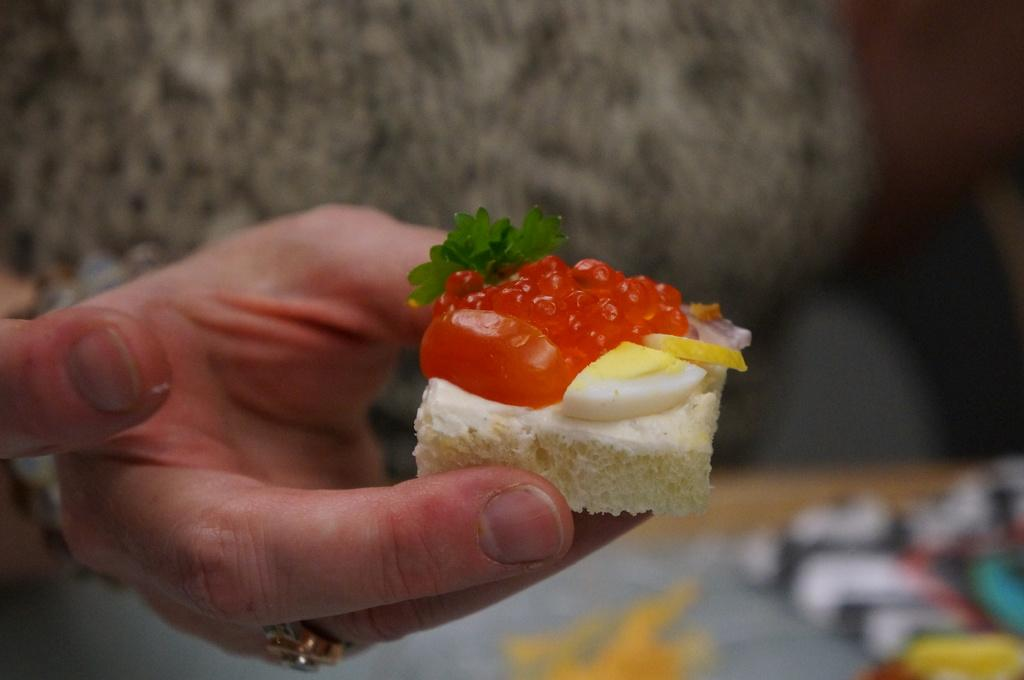What is the person holding in the image? There is a hand holding a piece of cake in the image. Can you describe the background of the image? The background of the image is blurred. What type of dog can be seen playing with a rat on the rail in the image? There is no dog, rat, or rail present in the image; it only features a hand holding a piece of cake with a blurred background. 